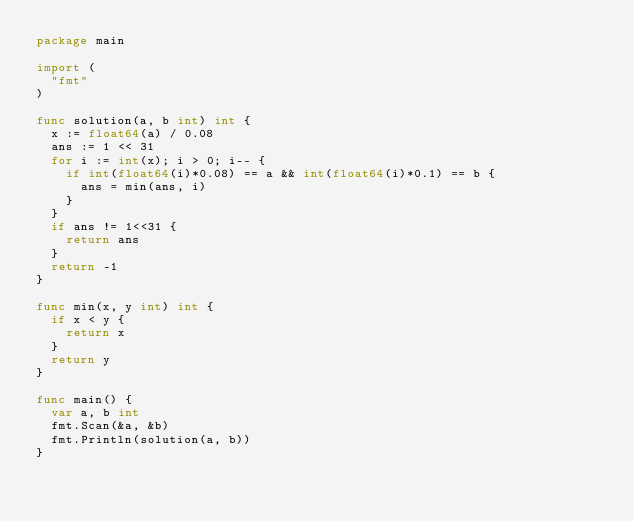Convert code to text. <code><loc_0><loc_0><loc_500><loc_500><_Go_>package main

import (
	"fmt"
)

func solution(a, b int) int {
	x := float64(a) / 0.08
	ans := 1 << 31
	for i := int(x); i > 0; i-- {
		if int(float64(i)*0.08) == a && int(float64(i)*0.1) == b {
			ans = min(ans, i)
		}
	}
	if ans != 1<<31 {
		return ans
	}
	return -1
}

func min(x, y int) int {
	if x < y {
		return x
	}
	return y
}

func main() {
	var a, b int
	fmt.Scan(&a, &b)
	fmt.Println(solution(a, b))
}
</code> 